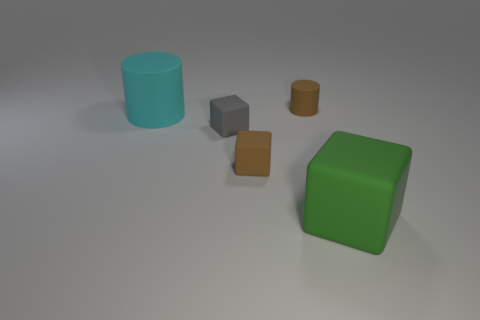Is there a matte object of the same color as the small rubber cylinder?
Offer a terse response. Yes. Is there a green rubber thing?
Offer a very short reply. Yes. Do the brown thing behind the cyan matte thing and the big cube have the same size?
Your answer should be compact. No. Is the number of big blue matte objects less than the number of things?
Offer a terse response. Yes. What is the shape of the thing that is to the right of the matte cylinder that is right of the small cube that is in front of the gray block?
Your response must be concise. Cube. Is there a brown object that has the same material as the tiny brown cylinder?
Your answer should be compact. Yes. There is a tiny thing in front of the gray thing; does it have the same color as the big matte object that is behind the big green matte object?
Your answer should be very brief. No. Is the number of large cyan matte cylinders that are to the right of the gray object less than the number of large green rubber things?
Your answer should be compact. Yes. How many things are either large green matte things or objects that are left of the big block?
Provide a short and direct response. 5. What color is the tiny cylinder that is the same material as the brown block?
Ensure brevity in your answer.  Brown. 